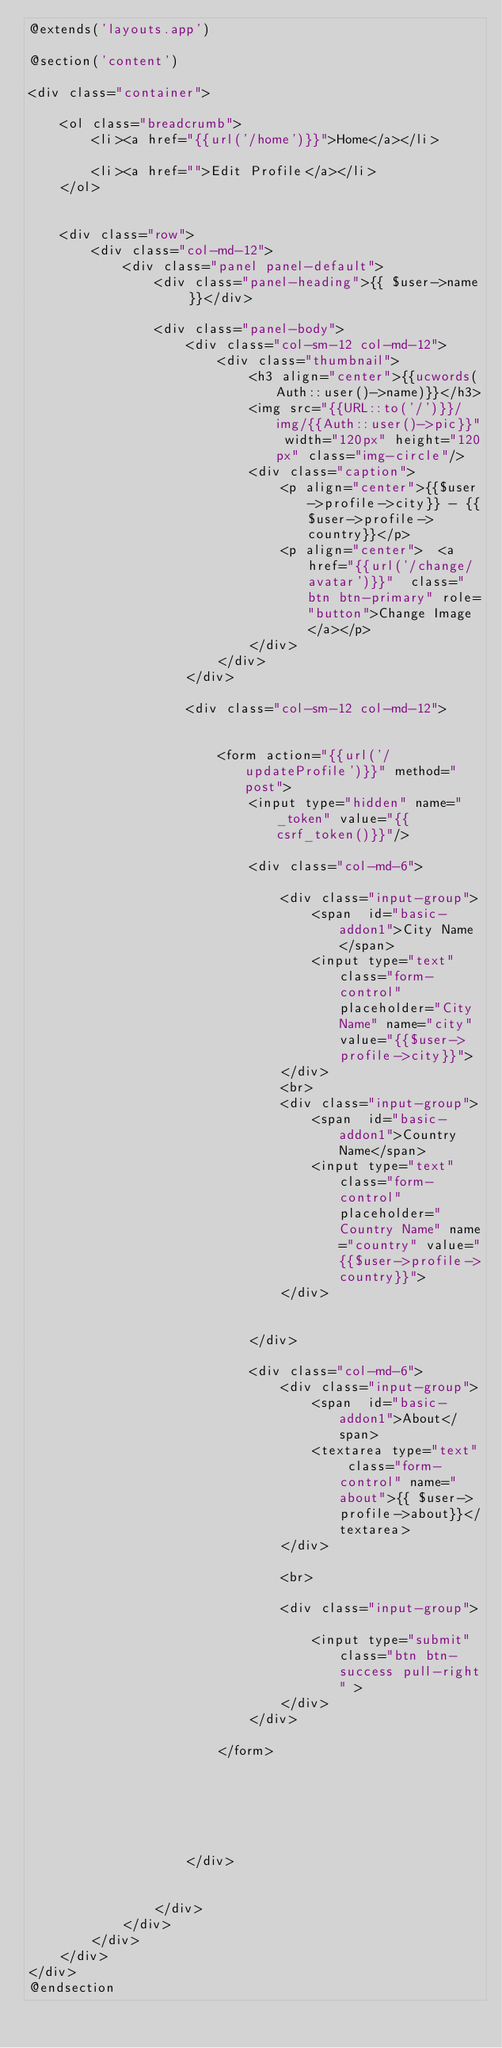Convert code to text. <code><loc_0><loc_0><loc_500><loc_500><_PHP_>@extends('layouts.app')

@section('content')

<div class="container">

    <ol class="breadcrumb">
        <li><a href="{{url('/home')}}">Home</a></li>
        
        <li><a href="">Edit Profile</a></li>
    </ol>


    <div class="row">
        <div class="col-md-12">
            <div class="panel panel-default">
                <div class="panel-heading">{{ $user->name }}</div>

                <div class="panel-body">
                    <div class="col-sm-12 col-md-12">
                        <div class="thumbnail">
                            <h3 align="center">{{ucwords(Auth::user()->name)}}</h3>
                            <img src="{{URL::to('/')}}/img/{{Auth::user()->pic}}" width="120px" height="120px" class="img-circle"/>
                            <div class="caption">
                                <p align="center">{{$user->profile->city}} - {{$user->profile->country}}</p>
                                <p align="center">  <a href="{{url('/change/avatar')}}"  class="btn btn-primary" role="button">Change Image</a></p>
                            </div>
                        </div>
                    </div>

                    <div class="col-sm-12 col-md-12">


                        <form action="{{url('/updateProfile')}}" method="post">
                            <input type="hidden" name="_token" value="{{csrf_token()}}"/>

                            <div class="col-md-6">

                                <div class="input-group">
                                    <span  id="basic-addon1">City Name</span>
                                    <input type="text" class="form-control" placeholder="City Name" name="city" value="{{$user->profile->city}}">
                                </div>
                                <br>
                                <div class="input-group">
                                    <span  id="basic-addon1">Country Name</span>
                                    <input type="text" class="form-control" placeholder="Country Name" name="country" value="{{$user->profile->country}}">
                                </div>


                            </div>

                            <div class="col-md-6">
                                <div class="input-group">
                                    <span  id="basic-addon1">About</span>
                                    <textarea type="text" class="form-control" name="about">{{ $user->profile->about}}</textarea>
                                </div>

                                <br>

                                <div class="input-group">

                                    <input type="submit" class="btn btn-success pull-right" >
                                </div>
                            </div>

                        </form>






                    </div>


                </div>
            </div>
        </div>
    </div>
</div>
@endsection
</code> 